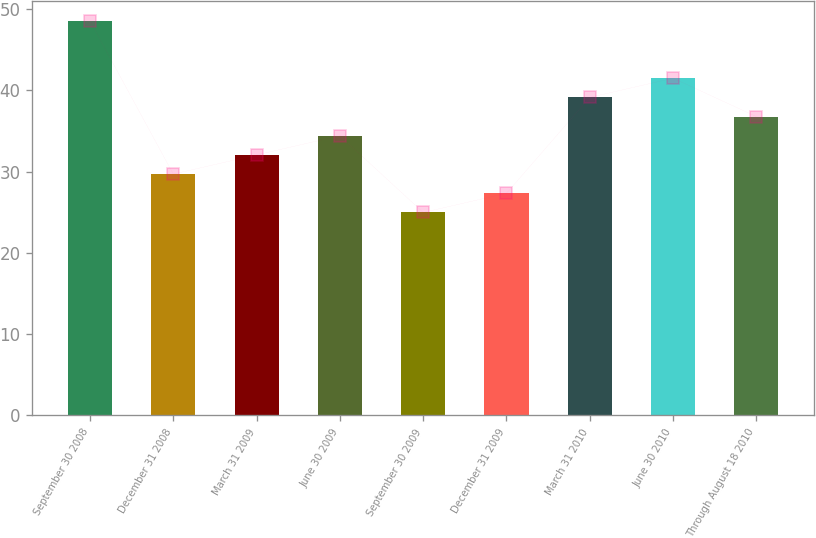Convert chart. <chart><loc_0><loc_0><loc_500><loc_500><bar_chart><fcel>September 30 2008<fcel>December 31 2008<fcel>March 31 2009<fcel>June 30 2009<fcel>September 30 2009<fcel>December 31 2009<fcel>March 31 2010<fcel>June 30 2010<fcel>Through August 18 2010<nl><fcel>48.54<fcel>29.69<fcel>32.05<fcel>34.41<fcel>24.97<fcel>27.33<fcel>39.13<fcel>41.49<fcel>36.77<nl></chart> 